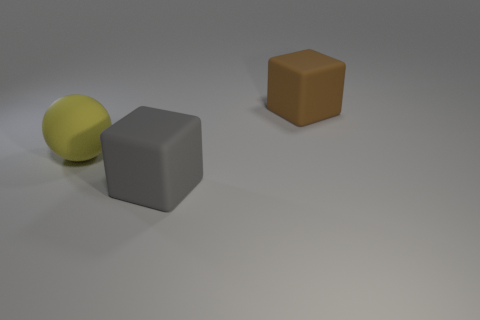How many other things are there of the same color as the rubber sphere?
Give a very brief answer. 0. What material is the gray cube?
Provide a short and direct response. Rubber. Does the brown cube that is on the right side of the gray block have the same size as the large yellow rubber sphere?
Ensure brevity in your answer.  Yes. Is there anything else that is the same size as the brown rubber block?
Keep it short and to the point. Yes. What is the size of the gray object that is the same shape as the brown rubber thing?
Your answer should be very brief. Large. Are there the same number of large gray cubes behind the big brown block and big things that are on the left side of the large yellow sphere?
Offer a terse response. Yes. There is a object in front of the yellow sphere; what is its size?
Make the answer very short. Large. Is there anything else that has the same shape as the gray object?
Provide a short and direct response. Yes. Is the number of big brown rubber objects that are to the left of the big gray matte thing the same as the number of small yellow shiny objects?
Ensure brevity in your answer.  Yes. There is a brown cube; are there any big matte things to the left of it?
Provide a succinct answer. Yes. 